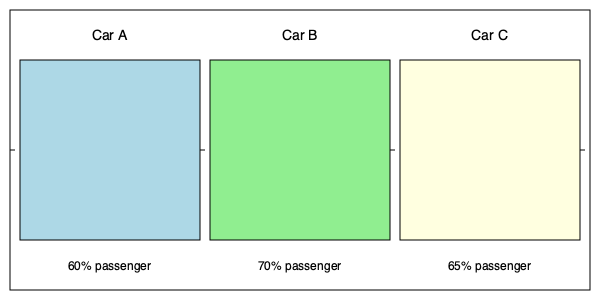Based on the cutaway diagrams of three subcompact cars shown above, which vehicle has the most efficient interior space utilization for passenger comfort? To determine the most efficient interior space utilization for passenger comfort, we need to analyze the passenger space allocation in each car:

1. Car A: 60% of interior space dedicated to passengers
2. Car B: 70% of interior space dedicated to passengers
3. Car C: 65% of interior space dedicated to passengers

The higher the percentage of interior space allocated to passengers, the more efficient the vehicle is in terms of passenger comfort.

Step-by-step analysis:
1. Compare Car A (60%) to Car B (70%):
   Car B has a higher percentage, so it's more efficient than Car A.

2. Compare Car B (70%) to Car C (65%):
   Car B still has a higher percentage, so it's more efficient than Car C.

3. Final comparison:
   Car B has the highest percentage of interior space dedicated to passengers at 70%.

Therefore, Car B has the most efficient interior space utilization for passenger comfort among the three subcompact cars shown.
Answer: Car B 